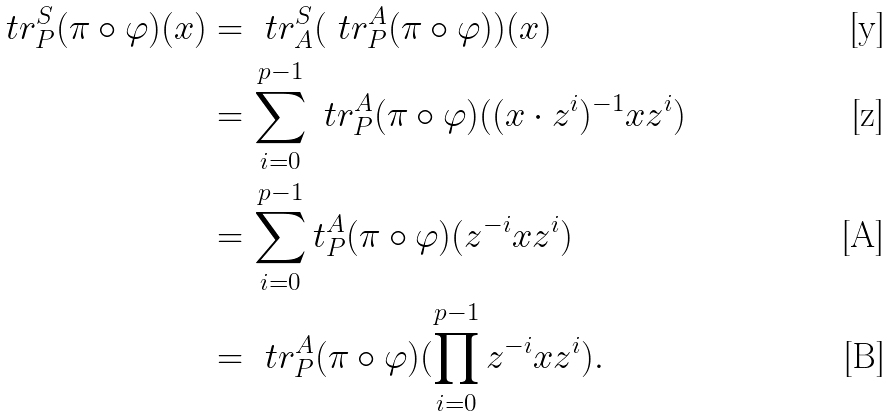<formula> <loc_0><loc_0><loc_500><loc_500>\ t r ^ { S } _ { P } ( \pi \circ \varphi ) ( x ) & = \ t r ^ { S } _ { A } ( \ t r ^ { A } _ { P } ( \pi \circ \varphi ) ) ( x ) \\ & = \sum _ { i = 0 } ^ { p - 1 } \ t r ^ { A } _ { P } ( \pi \circ \varphi ) ( ( x \cdot z ^ { i } ) ^ { - 1 } x z ^ { i } ) \\ & = \sum _ { i = 0 } ^ { p - 1 } t ^ { A } _ { P } ( \pi \circ \varphi ) ( z ^ { - i } x z ^ { i } ) \\ & = \ t r ^ { A } _ { P } ( \pi \circ \varphi ) ( \prod _ { i = 0 } ^ { p - 1 } z ^ { - i } x z ^ { i } ) .</formula> 